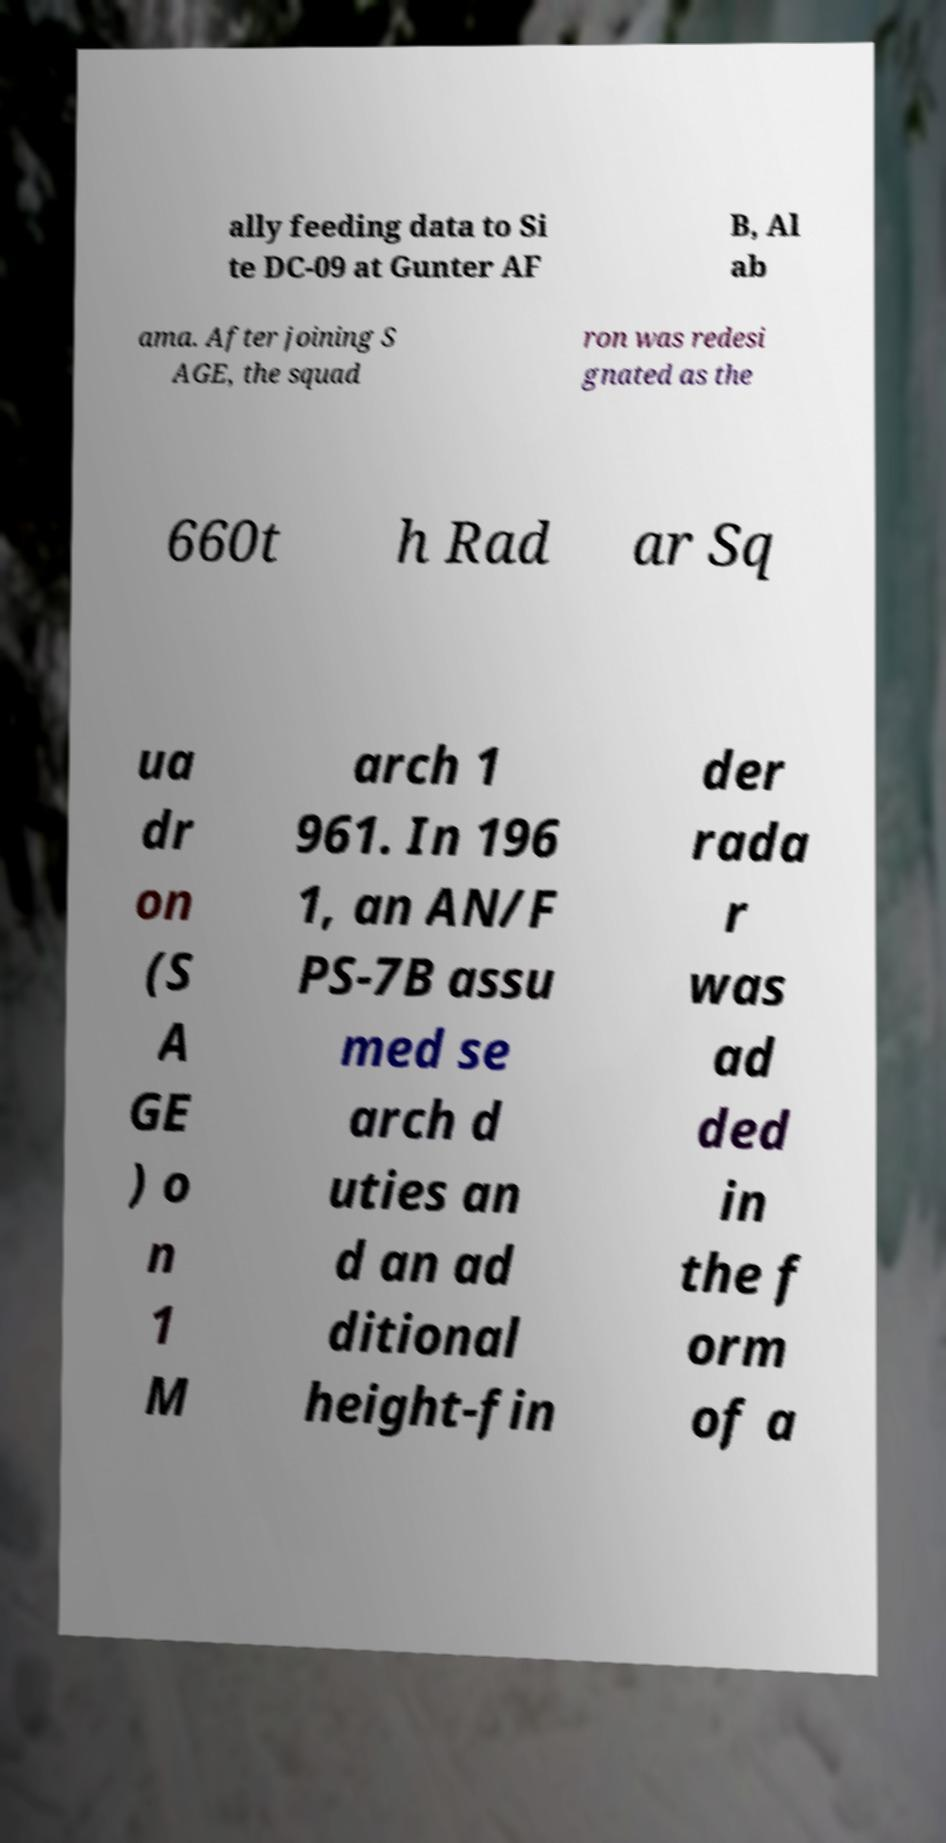Could you extract and type out the text from this image? ally feeding data to Si te DC-09 at Gunter AF B, Al ab ama. After joining S AGE, the squad ron was redesi gnated as the 660t h Rad ar Sq ua dr on (S A GE ) o n 1 M arch 1 961. In 196 1, an AN/F PS-7B assu med se arch d uties an d an ad ditional height-fin der rada r was ad ded in the f orm of a 